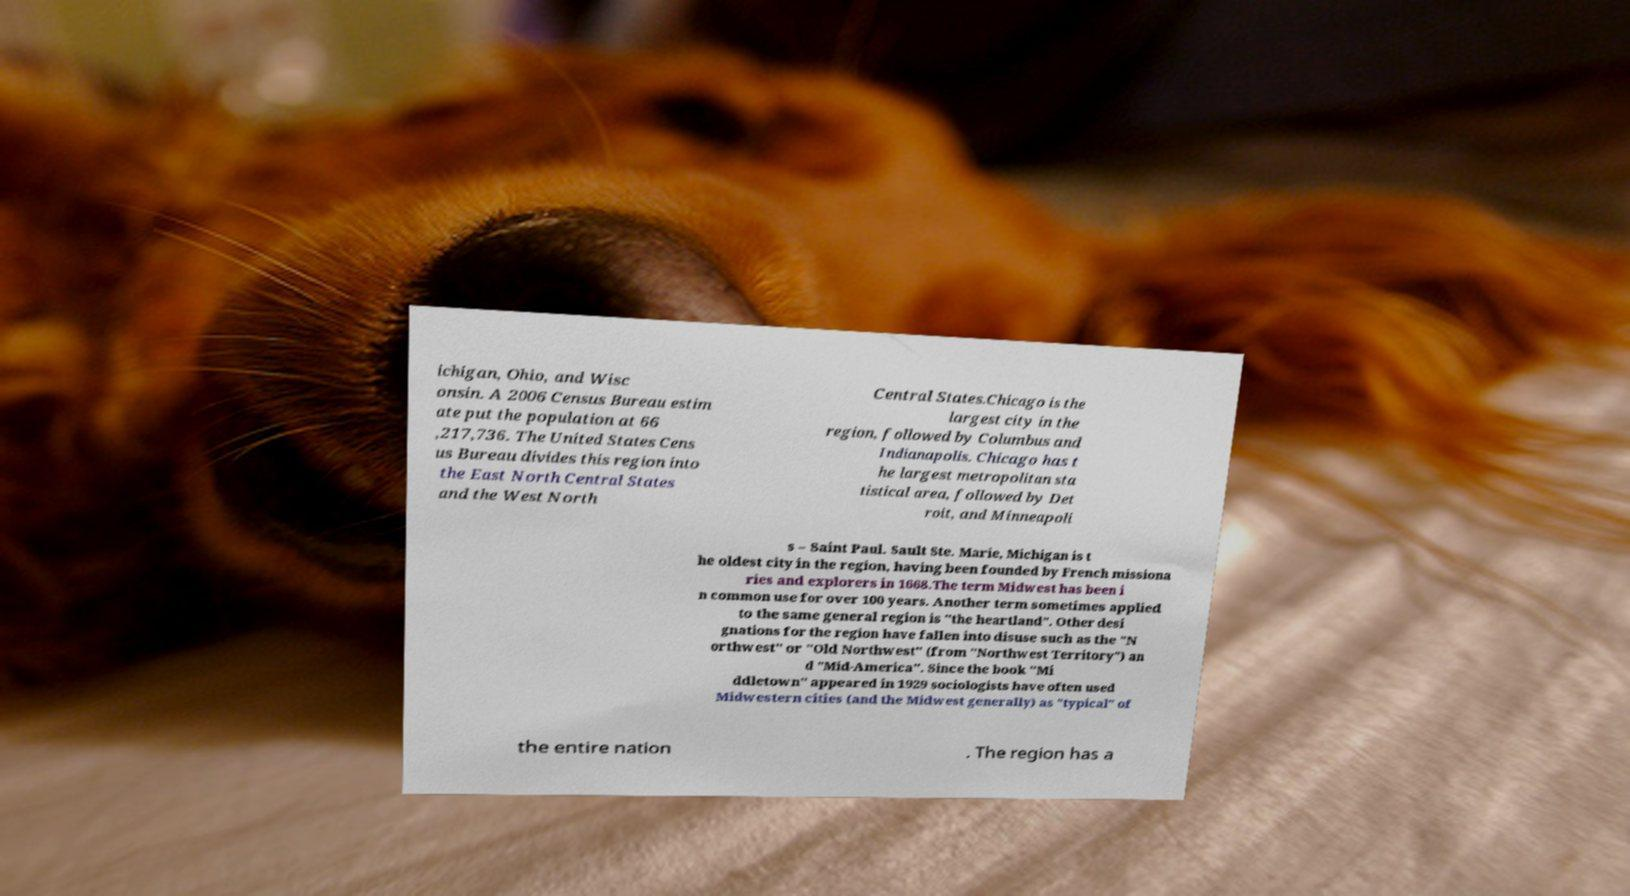What messages or text are displayed in this image? I need them in a readable, typed format. ichigan, Ohio, and Wisc onsin. A 2006 Census Bureau estim ate put the population at 66 ,217,736. The United States Cens us Bureau divides this region into the East North Central States and the West North Central States.Chicago is the largest city in the region, followed by Columbus and Indianapolis. Chicago has t he largest metropolitan sta tistical area, followed by Det roit, and Minneapoli s – Saint Paul. Sault Ste. Marie, Michigan is t he oldest city in the region, having been founded by French missiona ries and explorers in 1668.The term Midwest has been i n common use for over 100 years. Another term sometimes applied to the same general region is "the heartland". Other desi gnations for the region have fallen into disuse such as the "N orthwest" or "Old Northwest" (from "Northwest Territory") an d "Mid-America". Since the book "Mi ddletown" appeared in 1929 sociologists have often used Midwestern cities (and the Midwest generally) as "typical" of the entire nation . The region has a 